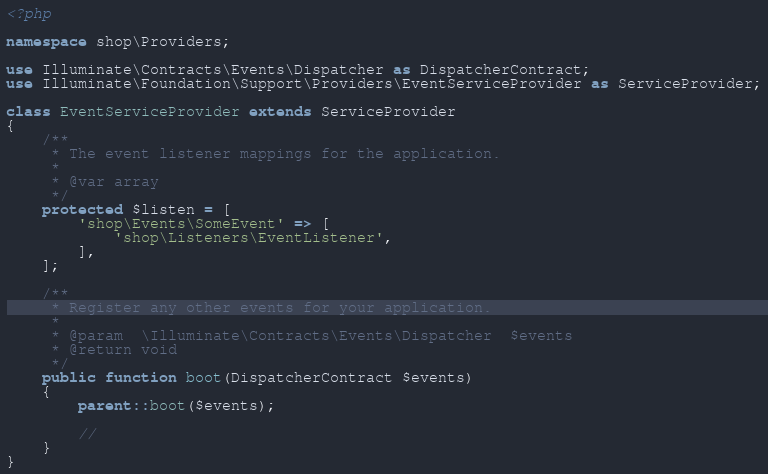Convert code to text. <code><loc_0><loc_0><loc_500><loc_500><_PHP_><?php

namespace shop\Providers;

use Illuminate\Contracts\Events\Dispatcher as DispatcherContract;
use Illuminate\Foundation\Support\Providers\EventServiceProvider as ServiceProvider;

class EventServiceProvider extends ServiceProvider
{
    /**
     * The event listener mappings for the application.
     *
     * @var array
     */
    protected $listen = [
        'shop\Events\SomeEvent' => [
            'shop\Listeners\EventListener',
        ],
    ];

    /**
     * Register any other events for your application.
     *
     * @param  \Illuminate\Contracts\Events\Dispatcher  $events
     * @return void
     */
    public function boot(DispatcherContract $events)
    {
        parent::boot($events);

        //
    }
}
</code> 